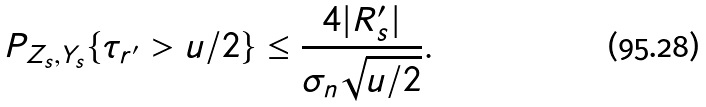Convert formula to latex. <formula><loc_0><loc_0><loc_500><loc_500>P _ { Z _ { s } , Y _ { s } } \{ \tau _ { r ^ { \prime } } > u / 2 \} \leq \frac { 4 | R _ { s } ^ { \prime } | } { \sigma _ { n } \sqrt { u / 2 } } .</formula> 